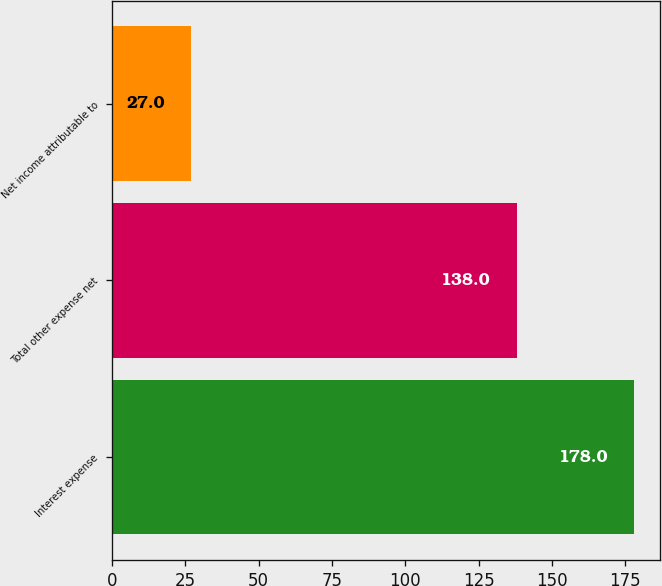Convert chart. <chart><loc_0><loc_0><loc_500><loc_500><bar_chart><fcel>Interest expense<fcel>Total other expense net<fcel>Net income attributable to<nl><fcel>178<fcel>138<fcel>27<nl></chart> 